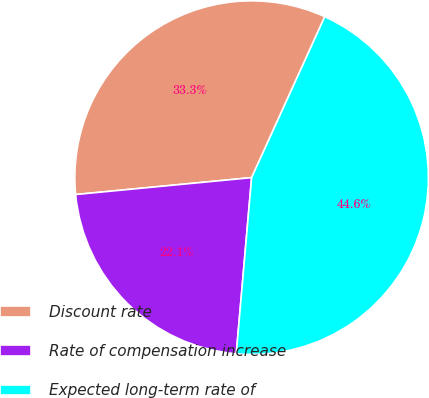<chart> <loc_0><loc_0><loc_500><loc_500><pie_chart><fcel>Discount rate<fcel>Rate of compensation increase<fcel>Expected long-term rate of<nl><fcel>33.31%<fcel>22.09%<fcel>44.59%<nl></chart> 